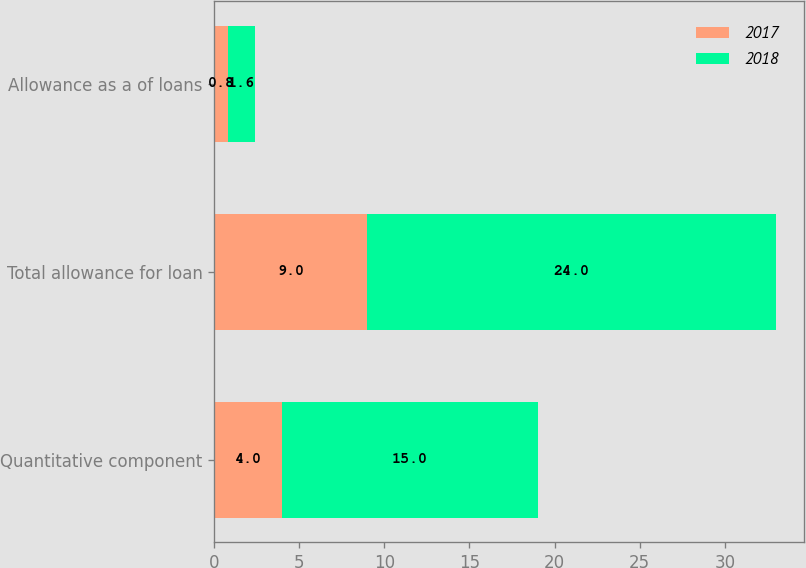<chart> <loc_0><loc_0><loc_500><loc_500><stacked_bar_chart><ecel><fcel>Quantitative component<fcel>Total allowance for loan<fcel>Allowance as a of loans<nl><fcel>2017<fcel>4<fcel>9<fcel>0.8<nl><fcel>2018<fcel>15<fcel>24<fcel>1.6<nl></chart> 